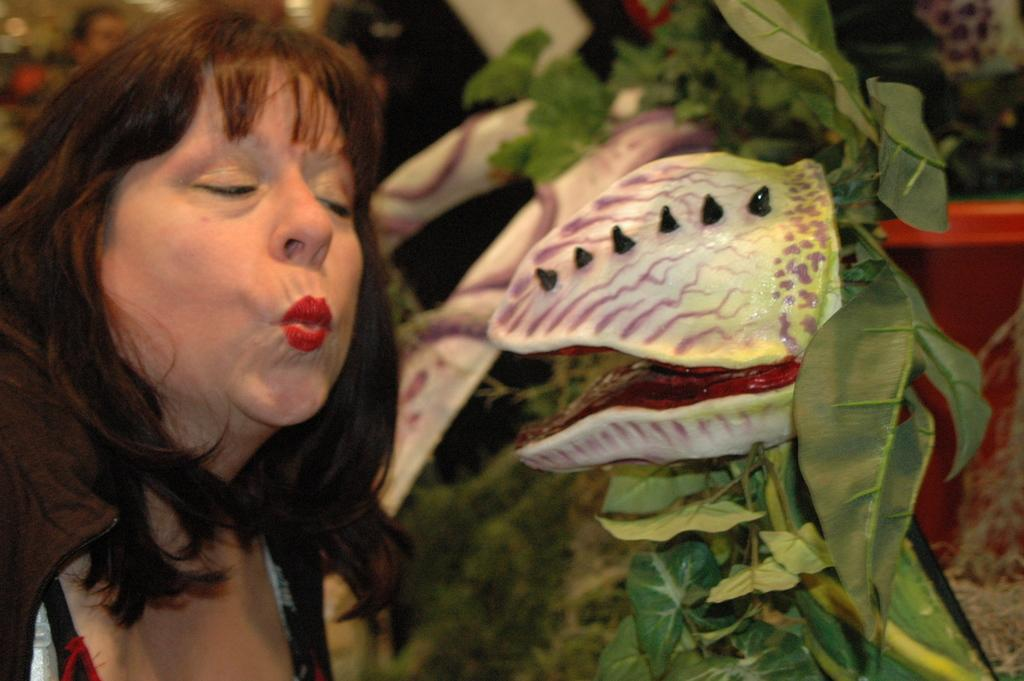What is the main subject of the image? The main subject of the image is a woman. What is the woman doing in the image? The woman is making different actions with her mouth. Are there any natural elements present in the image? Yes, there are leaves in the image. What time is displayed on the clock in the image? There is no clock present in the image; it only features a woman making different actions with her mouth and leaves. 